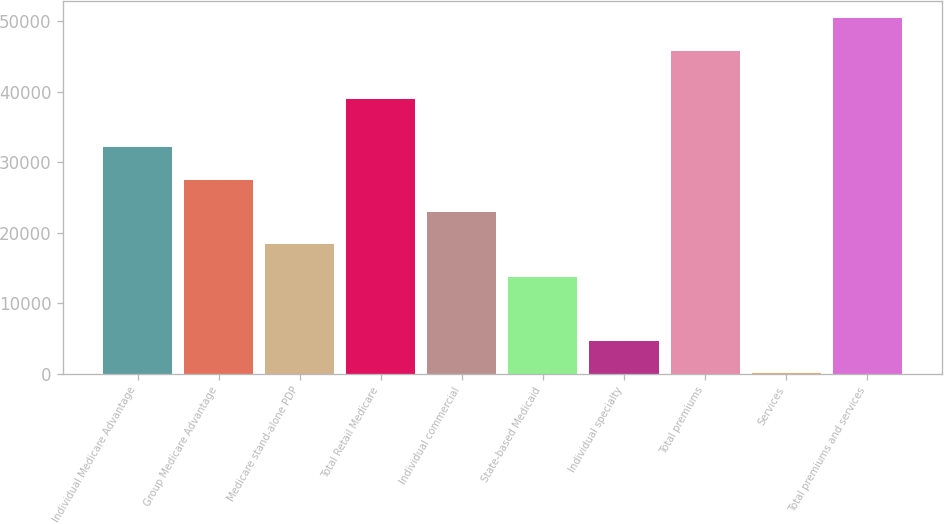Convert chart to OTSL. <chart><loc_0><loc_0><loc_500><loc_500><bar_chart><fcel>Individual Medicare Advantage<fcel>Group Medicare Advantage<fcel>Medicare stand-alone PDP<fcel>Total Retail Medicare<fcel>Individual commercial<fcel>State-based Medicaid<fcel>Individual specialty<fcel>Total premiums<fcel>Services<fcel>Total premiums and services<nl><fcel>32072.5<fcel>27492<fcel>18331<fcel>38960<fcel>22911.5<fcel>13750.5<fcel>4589.5<fcel>45805<fcel>9<fcel>50385.5<nl></chart> 